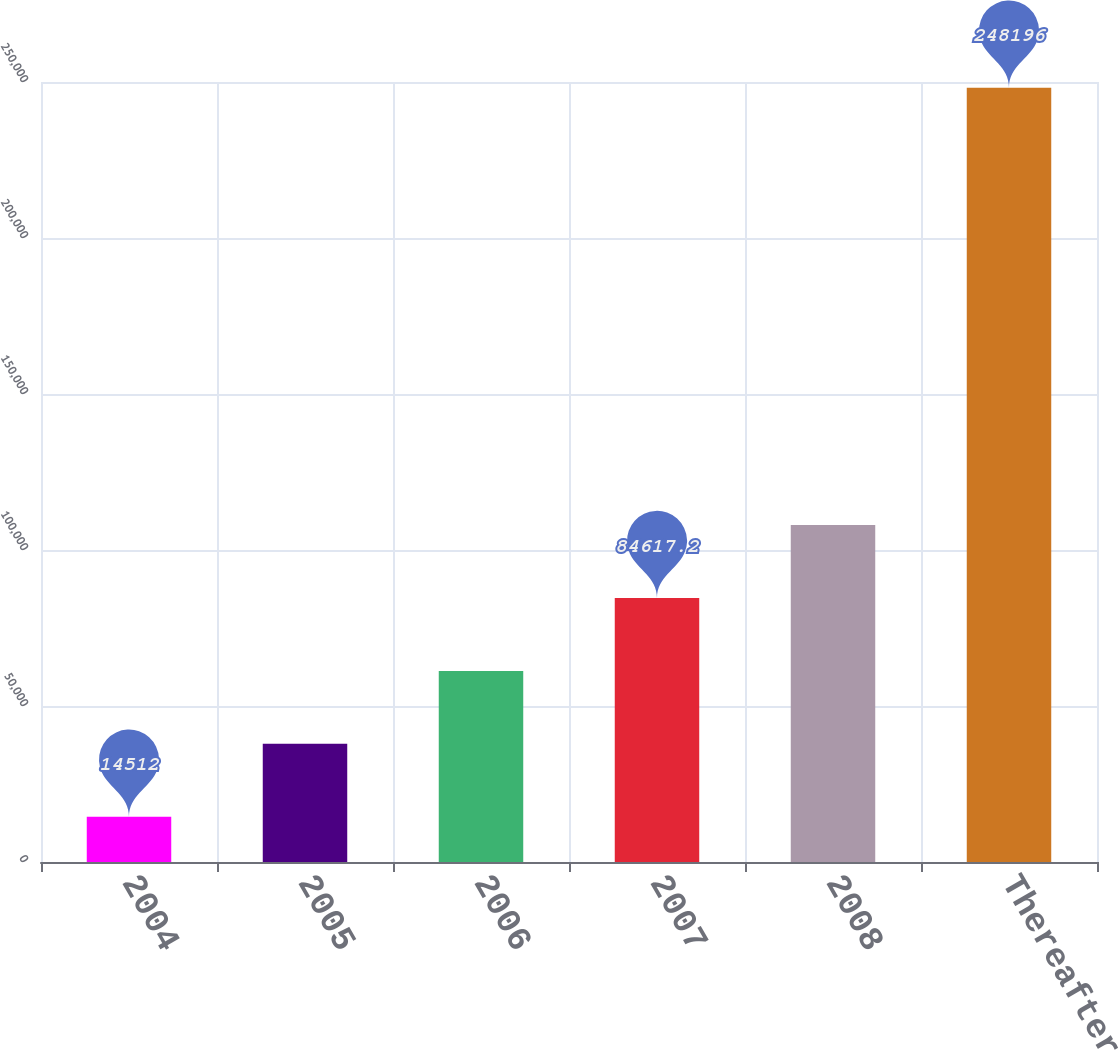<chart> <loc_0><loc_0><loc_500><loc_500><bar_chart><fcel>2004<fcel>2005<fcel>2006<fcel>2007<fcel>2008<fcel>Thereafter<nl><fcel>14512<fcel>37880.4<fcel>61248.8<fcel>84617.2<fcel>107986<fcel>248196<nl></chart> 